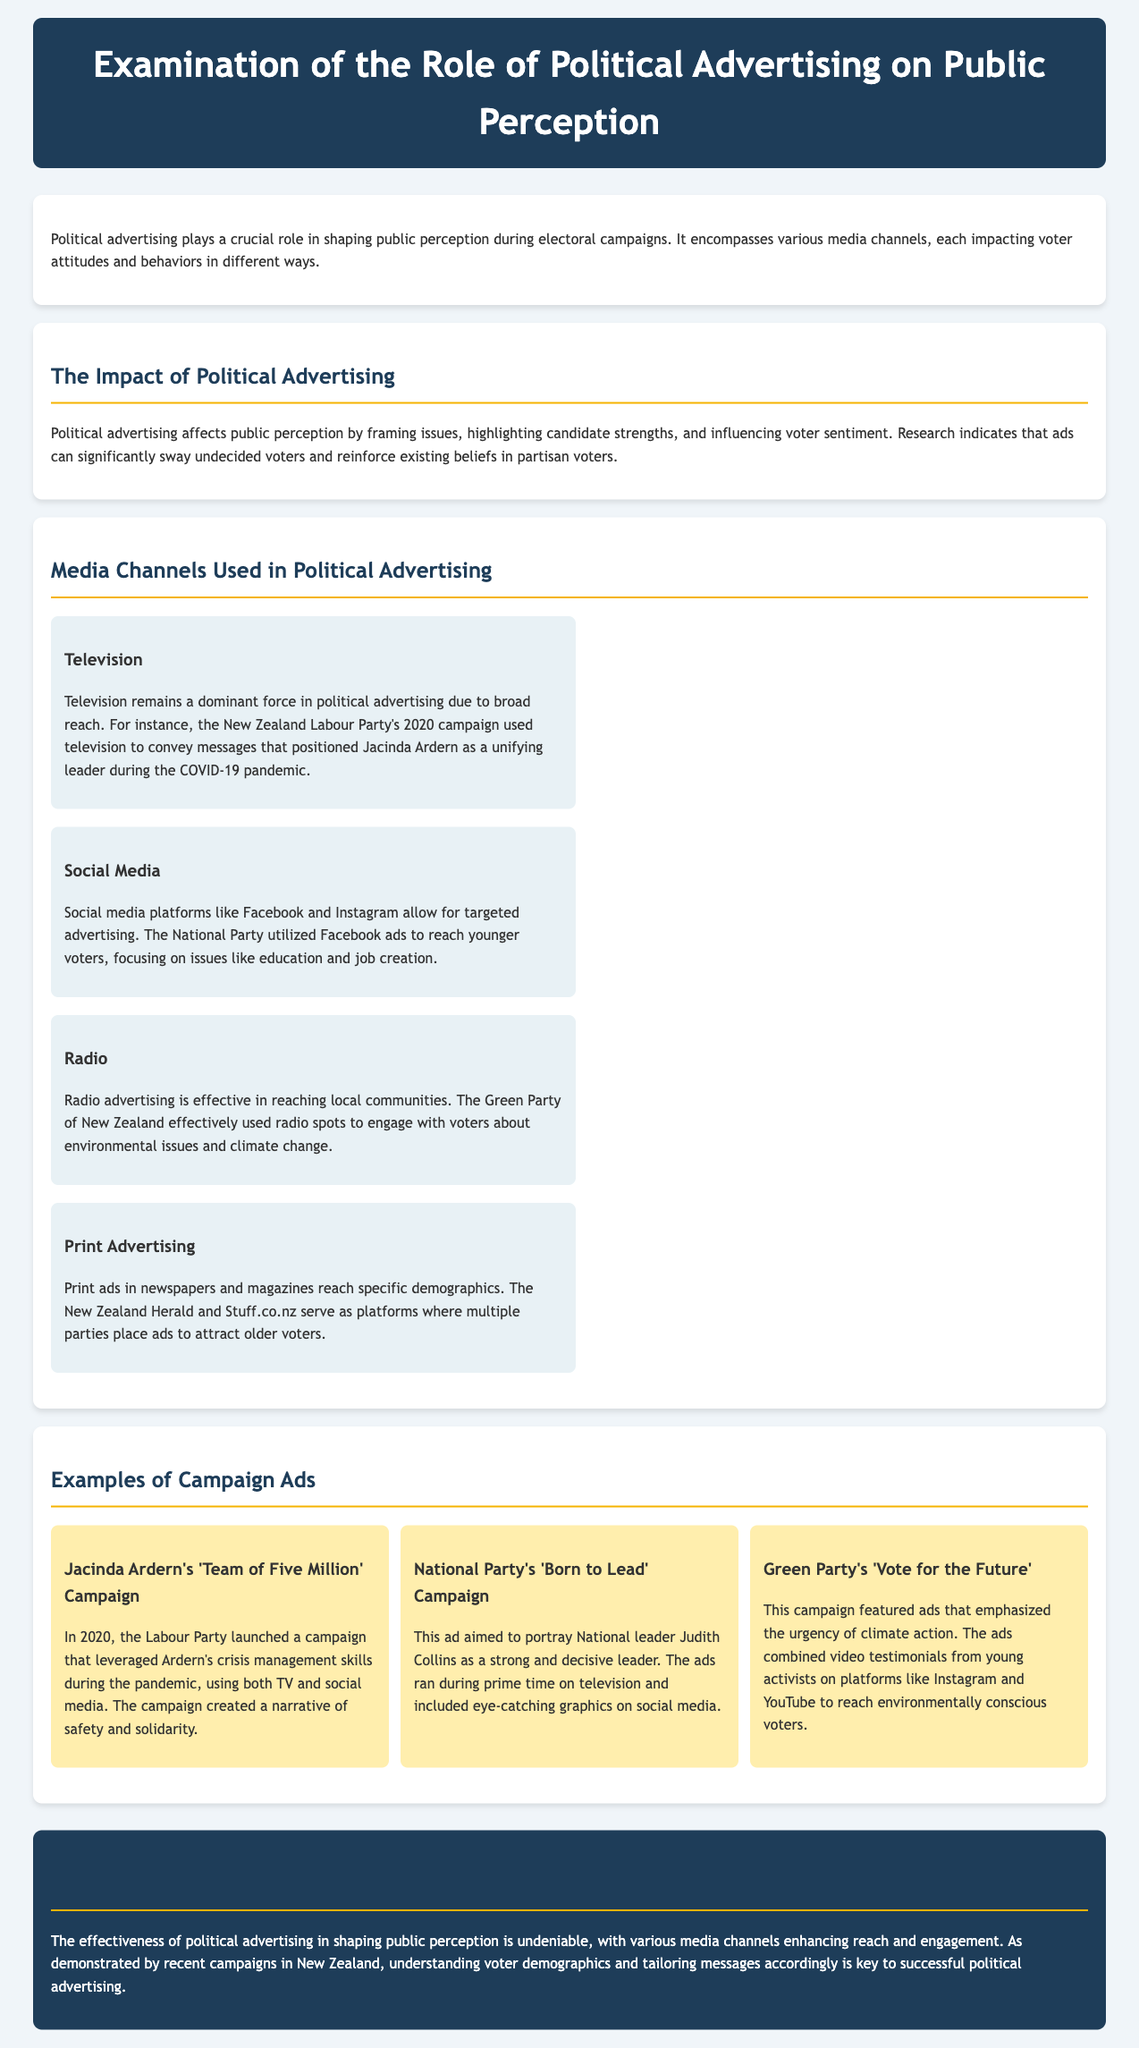what role does political advertising play? Political advertising plays a crucial role in shaping public perception during electoral campaigns.
Answer: shaping public perception which party's campaign used the 'Team of Five Million' slogan? The 'Team of Five Million' campaign was launched by the Labour Party in 2020.
Answer: Labour Party what media channel is described as effective for reaching local communities? Radio advertising is effective in reaching local communities.
Answer: Radio who was portrayed as a strong leader in the National Party's campaign? Judith Collins was portrayed as a strong and decisive leader in the National Party's campaign.
Answer: Judith Collins what issue did the Green Party focus on in their campaign ads? The Green Party focused on environmental issues and climate change in their campaign ads.
Answer: environmental issues which platform did the National Party use to reach younger voters? The National Party utilized Facebook ads to reach younger voters.
Answer: Facebook what was the main narrative of Jacinda Ardern's 2020 campaign? The campaign created a narrative of safety and solidarity.
Answer: safety and solidarity how do media channels enhance reach in political advertising? Various media channels enhance reach and engagement in political advertising.
Answer: reach and engagement what is the conclusion regarding political advertising effectiveness? The effectiveness of political advertising in shaping public perception is undeniable.
Answer: effectiveness is undeniable 